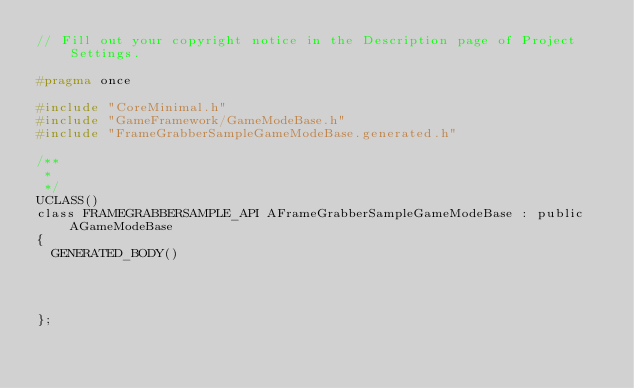<code> <loc_0><loc_0><loc_500><loc_500><_C_>// Fill out your copyright notice in the Description page of Project Settings.

#pragma once

#include "CoreMinimal.h"
#include "GameFramework/GameModeBase.h"
#include "FrameGrabberSampleGameModeBase.generated.h"

/**
 * 
 */
UCLASS()
class FRAMEGRABBERSAMPLE_API AFrameGrabberSampleGameModeBase : public AGameModeBase
{
	GENERATED_BODY()
	
	
	
	
};
</code> 